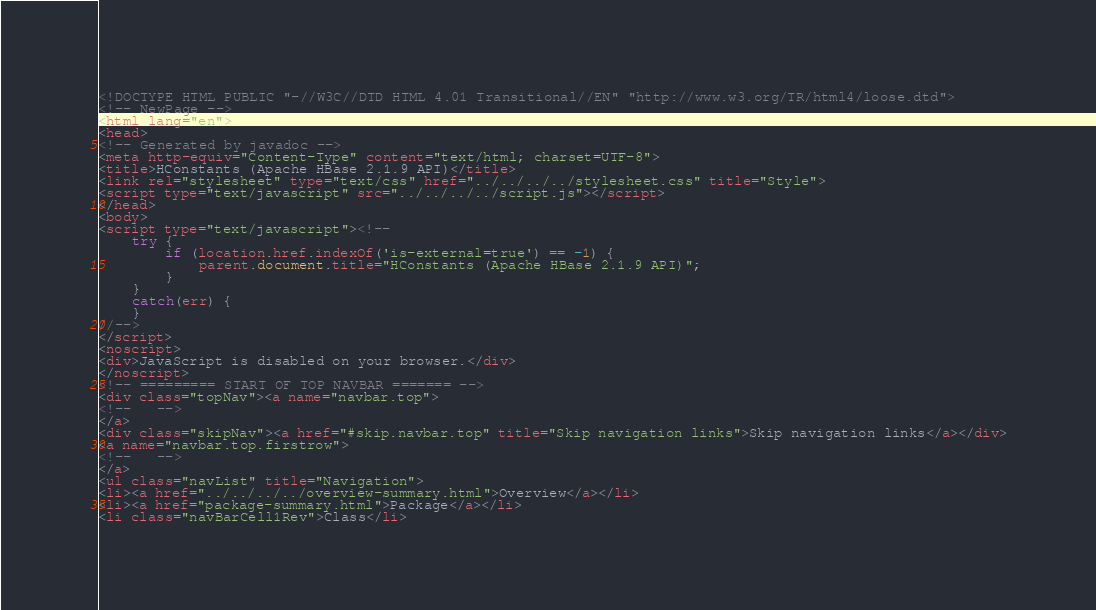<code> <loc_0><loc_0><loc_500><loc_500><_HTML_><!DOCTYPE HTML PUBLIC "-//W3C//DTD HTML 4.01 Transitional//EN" "http://www.w3.org/TR/html4/loose.dtd">
<!-- NewPage -->
<html lang="en">
<head>
<!-- Generated by javadoc -->
<meta http-equiv="Content-Type" content="text/html; charset=UTF-8">
<title>HConstants (Apache HBase 2.1.9 API)</title>
<link rel="stylesheet" type="text/css" href="../../../../stylesheet.css" title="Style">
<script type="text/javascript" src="../../../../script.js"></script>
</head>
<body>
<script type="text/javascript"><!--
    try {
        if (location.href.indexOf('is-external=true') == -1) {
            parent.document.title="HConstants (Apache HBase 2.1.9 API)";
        }
    }
    catch(err) {
    }
//-->
</script>
<noscript>
<div>JavaScript is disabled on your browser.</div>
</noscript>
<!-- ========= START OF TOP NAVBAR ======= -->
<div class="topNav"><a name="navbar.top">
<!--   -->
</a>
<div class="skipNav"><a href="#skip.navbar.top" title="Skip navigation links">Skip navigation links</a></div>
<a name="navbar.top.firstrow">
<!--   -->
</a>
<ul class="navList" title="Navigation">
<li><a href="../../../../overview-summary.html">Overview</a></li>
<li><a href="package-summary.html">Package</a></li>
<li class="navBarCell1Rev">Class</li></code> 